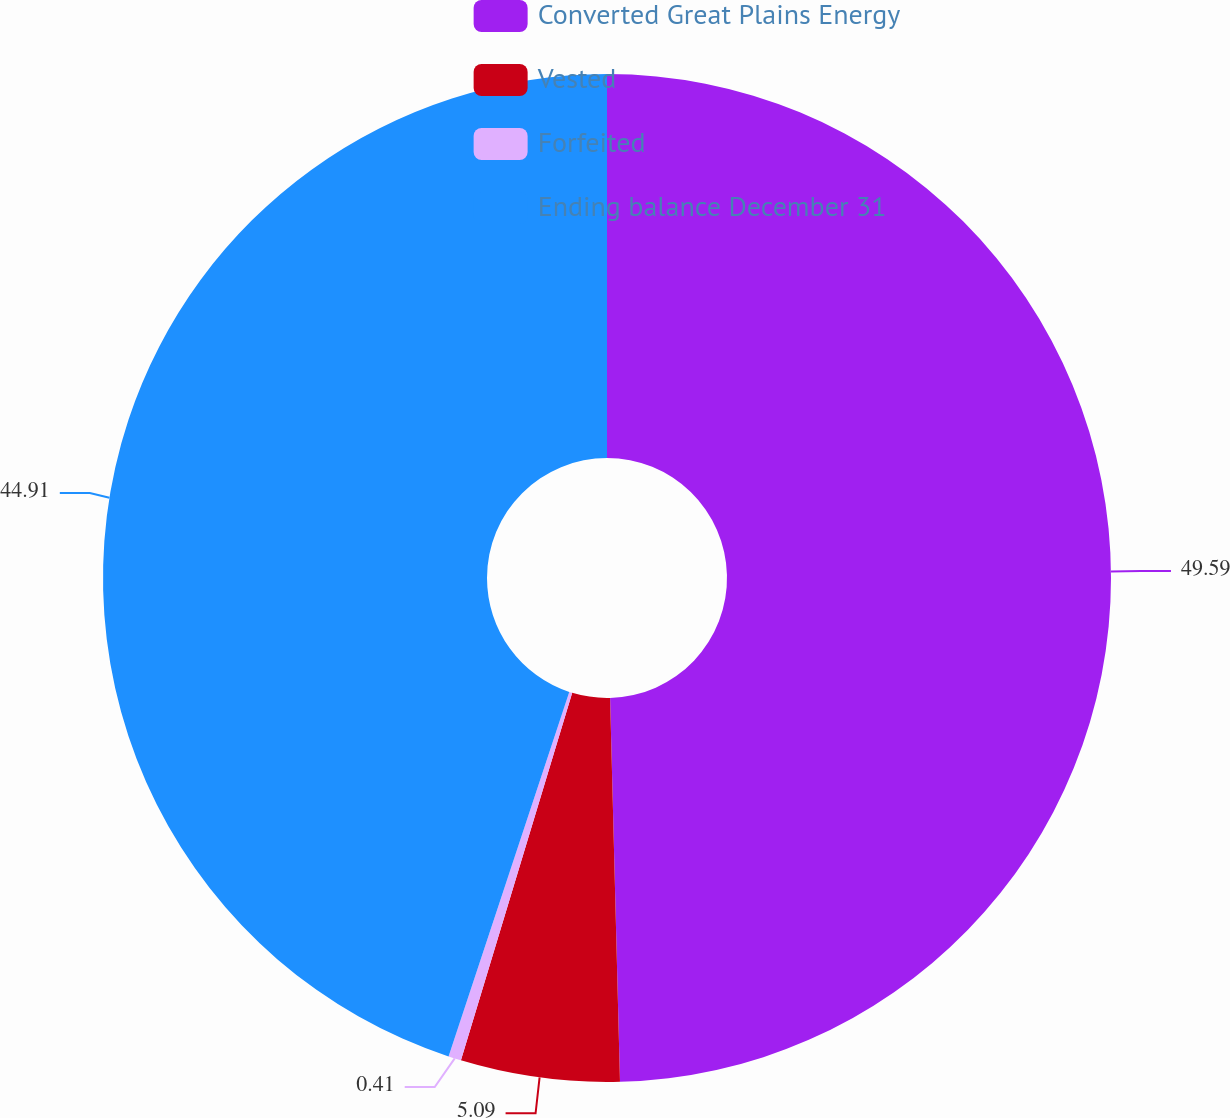Convert chart to OTSL. <chart><loc_0><loc_0><loc_500><loc_500><pie_chart><fcel>Converted Great Plains Energy<fcel>Vested<fcel>Forfeited<fcel>Ending balance December 31<nl><fcel>49.59%<fcel>5.09%<fcel>0.41%<fcel>44.91%<nl></chart> 